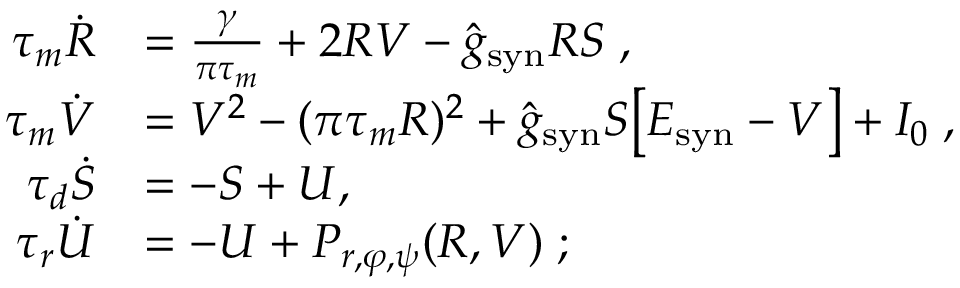<formula> <loc_0><loc_0><loc_500><loc_500>\begin{array} { r l } { \tau _ { m } \dot { R } } & { = \frac { \gamma } { \pi \tau _ { m } } + 2 R V - \hat { g } _ { s y n } R S \, , } \\ { \tau _ { m } \dot { V } } & { = V ^ { 2 } - ( \pi \tau _ { m } R ) ^ { 2 } + \hat { g } _ { s y n } S \left [ E _ { s y n } - V \right ] + I _ { 0 } \, , } \\ { \tau _ { d } \dot { S } } & { = - S + U , \, } \\ { \tau _ { r } \dot { U } } & { = - U + P _ { r , \varphi , \psi } ( R , V ) \, ; } \end{array}</formula> 